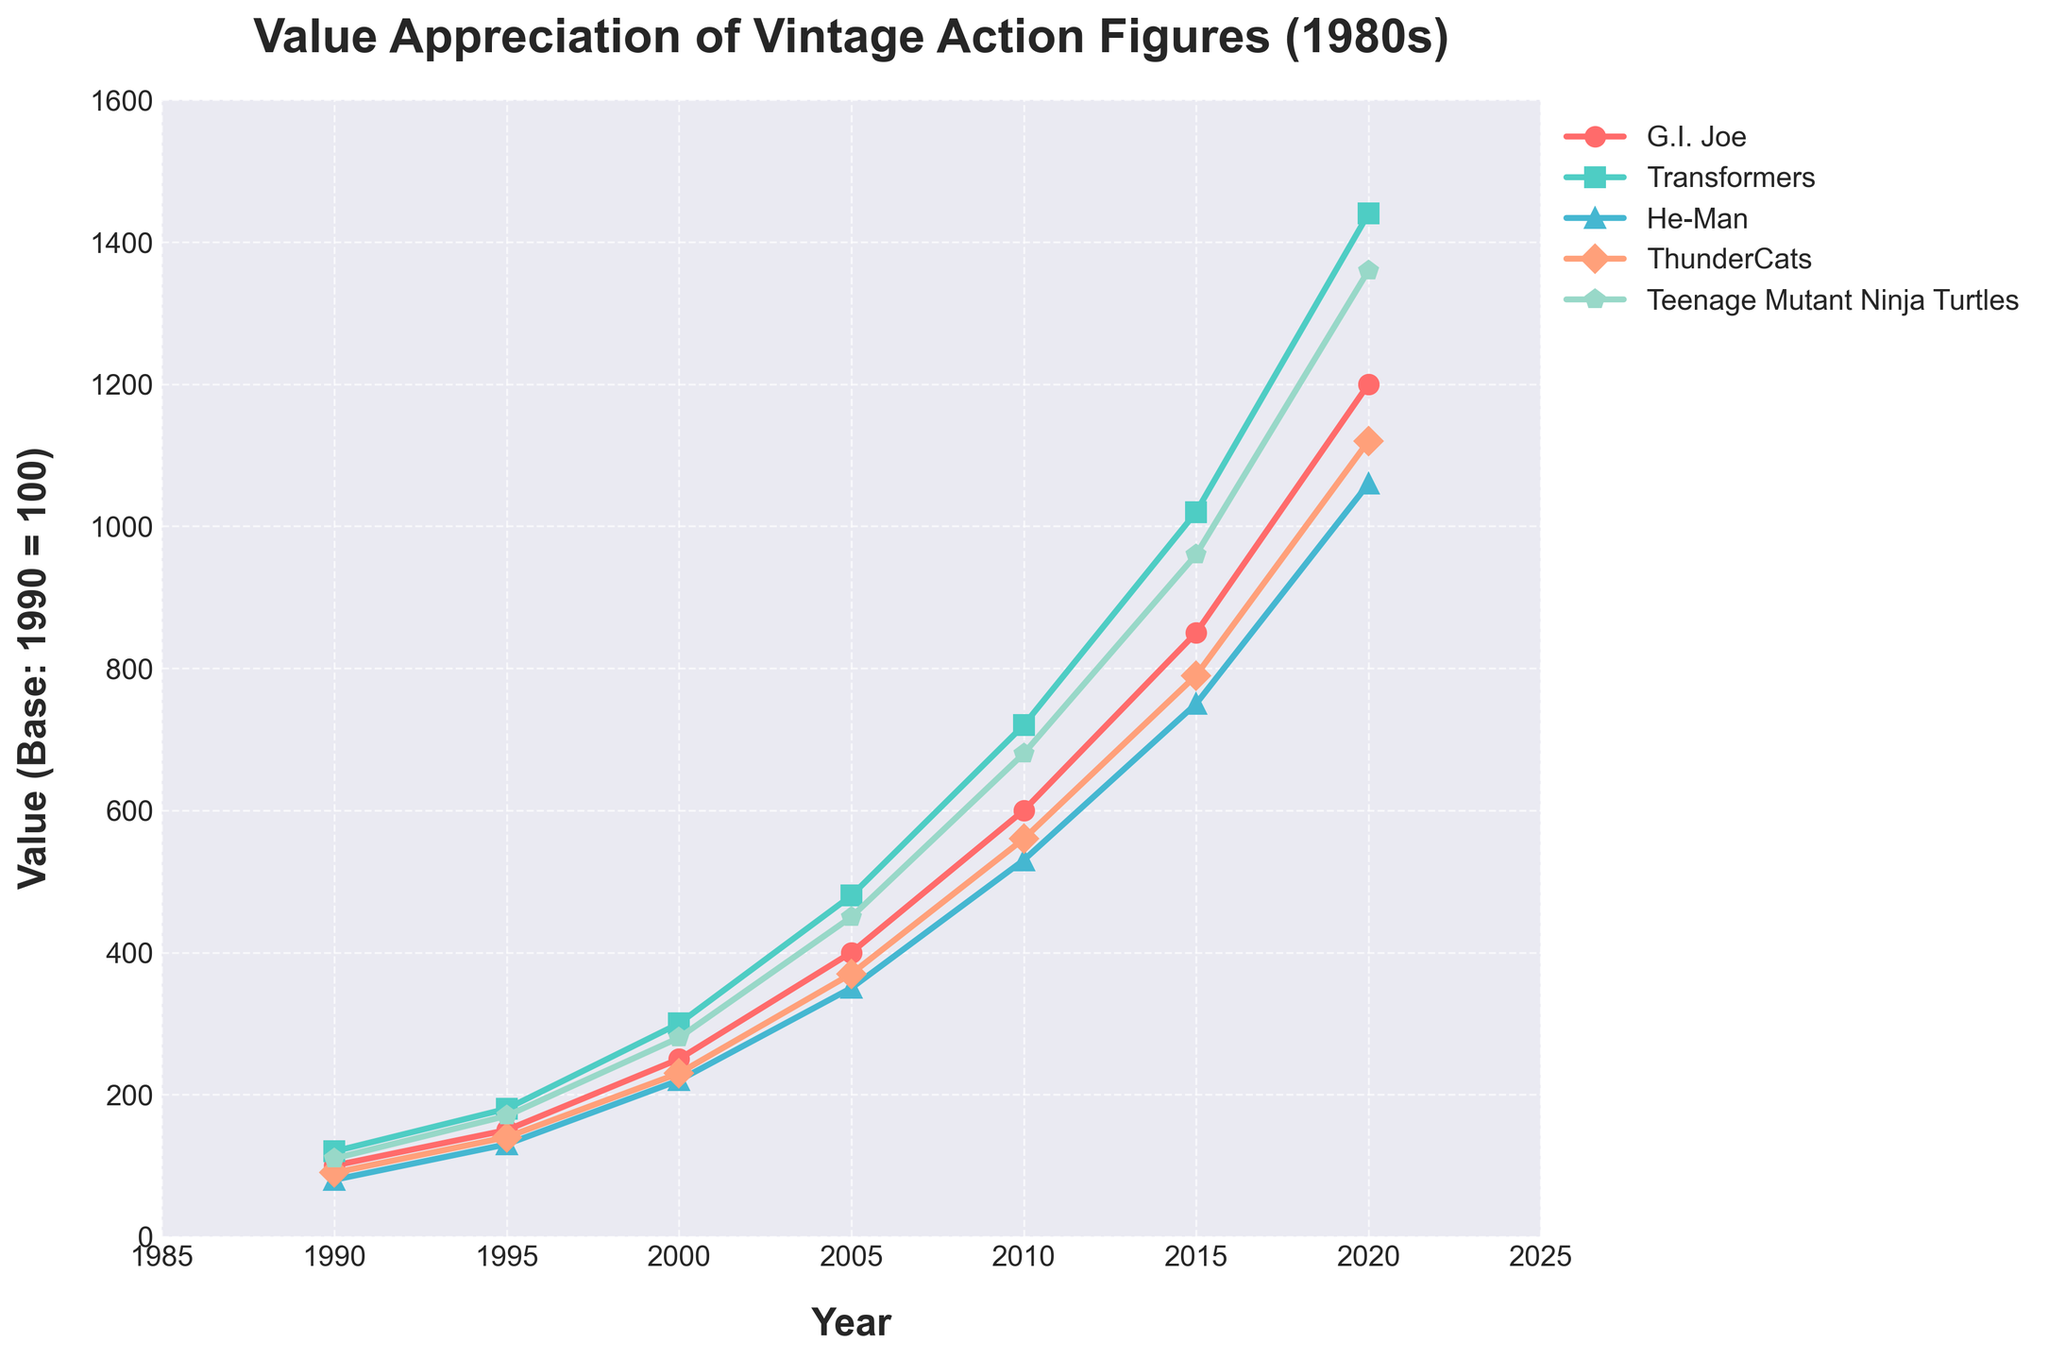Which toy line showed the highest value appreciation from 1990 to 2020? To determine which toy line had the highest value increase, we need to calculate the increase for each toy line from 1990 to 2020 and compare the results. 
- G.I. Joe: 1200 - 100 = 1100
- Transformers: 1440 - 120 = 1320
- He-Man: 1060 - 80 = 980
- ThunderCats: 1120 - 90 = 1030
- Teenage Mutant Ninja Turtles: 1360 - 110 = 1250
The highest value appreciation is 1320, which belongs to the Transformers.
Answer: Transformers Which year showed the greatest increase in value for G.I. Joe action figures? To find this, we compare the value increases between each consecutive year for G.I. Joe:
- 1995-1990: 150 - 100 = 50
- 2000-1995: 250 - 150 = 100
- 2005-2000: 400 - 250 = 150
- 2010-2005: 600 - 400 = 200
- 2015-2010: 850 - 600 = 250
- 2020-2015: 1200 - 850 = 350
The greatest increase occurred between 2015 and 2020 with an increase of 350.
Answer: 2015 to 2020 By how much did the value of Teenage Mutant Ninja Turtles exceed ThunderCats in 2020? To answer, we subtract the value of ThunderCats from the value of Teenage Mutant Ninja Turtles for the year 2020:
- 1360 (Teenage Mutant Ninja Turtles) - 1120 (ThunderCats) = 240
Answer: 240 What was the average value of Transformers figures over all the years provided? We sum up all the values of Transformers figures and divide by the number of years:
- Sum = 120 + 180 + 300 + 480 + 720 + 1020 + 1440 = 4260
- Average = 4260 / 7 = 609
Answer: 609 Which toy line had the slowest rate of appreciation from 1995 to 2000? To find out which toy line had the slowest appreciation rate, we calculate the increase for each toy line from 1995 to 2000:
- G.I. Joe: 250 - 150 = 100
- Transformers: 300 - 180 = 120
- He-Man: 220 - 130 = 90
- ThunderCats: 230 - 140 = 90
- Teenage Mutant Ninja Turtles: 280 - 170 = 110
The slowest appreciation rates are He-Man and ThunderCats, each with an increase of 90.
Answer: He-Man and ThunderCats In which year did value appreciation for He-Man figures cross the 500 mark? To find this, we locate the first year in the dataset where He-Man figures’ value exceeds 500:
- 1990: 80
- 1995: 130
- 2000: 220
- 2005: 350
- 2010: 530
The value first crossed 500 in the year 2010.
Answer: 2010 Which toy line showed the largest percentage increase from 2005 to 2010? To find the largest percentage increase, we calculate as follows for each toy line:
- G.I. Joe: (600 - 400) / 400 * 100 = 50%
- Transformers: (720 - 480) / 480 * 100 = 50%
- He-Man: (530 - 350) / 350 * 100 = 51.43%
- ThunderCats: (560 - 370) / 370 * 100 = 51.35%
- Teenage Mutant Ninja Turtles: (680 - 450) / 450 * 100 = 51.11%
He-Man had the largest percentage increase of 51.43%.
Answer: He-Man 